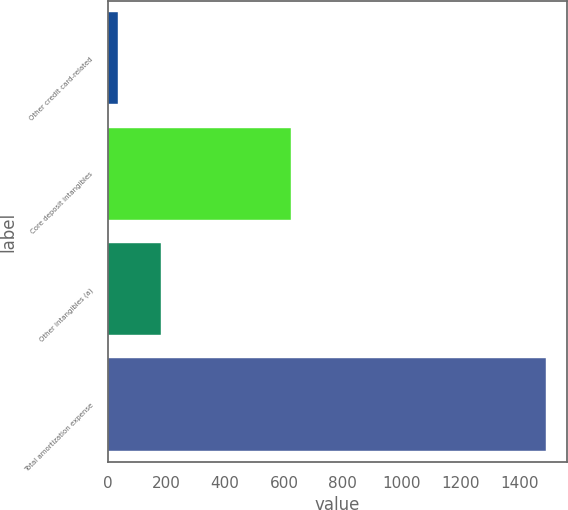<chart> <loc_0><loc_0><loc_500><loc_500><bar_chart><fcel>Other credit card-related<fcel>Core deposit intangibles<fcel>Other intangibles (a)<fcel>Total amortization expense<nl><fcel>36<fcel>623<fcel>181.4<fcel>1490<nl></chart> 